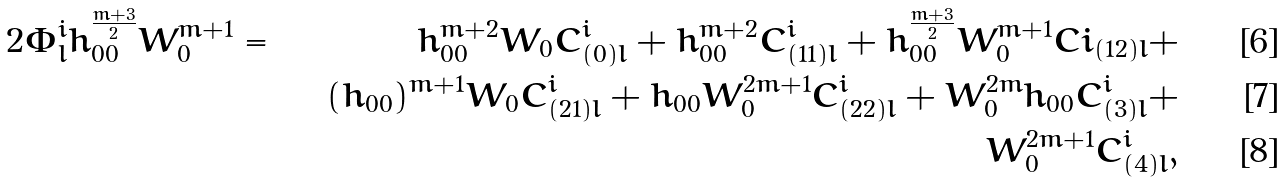Convert formula to latex. <formula><loc_0><loc_0><loc_500><loc_500>2 \Phi ^ { i } _ { l } h _ { 0 0 } ^ { \frac { m + 3 } { 2 } } W _ { 0 } ^ { m + 1 } & = & h _ { 0 0 } ^ { m + 2 } W _ { 0 } C ^ { i } _ { ( 0 ) l } + h _ { 0 0 } ^ { m + 2 } C ^ { i } _ { ( 1 1 ) l } + h _ { 0 0 } ^ { \frac { m + 3 } { 2 } } W _ { 0 } ^ { m + 1 } C i _ { ( 1 2 ) l } + \\ & & ( h _ { 0 0 } ) ^ { m + 1 } W _ { 0 } C ^ { i } _ { ( 2 1 ) l } + h _ { 0 0 } W _ { 0 } ^ { 2 m + 1 } C ^ { i } _ { ( 2 2 ) l } + W _ { 0 } ^ { 2 m } h _ { 0 0 } C ^ { i } _ { ( 3 ) l } + \\ & & W _ { 0 } ^ { 2 m + 1 } C ^ { i } _ { ( 4 ) l } ,</formula> 